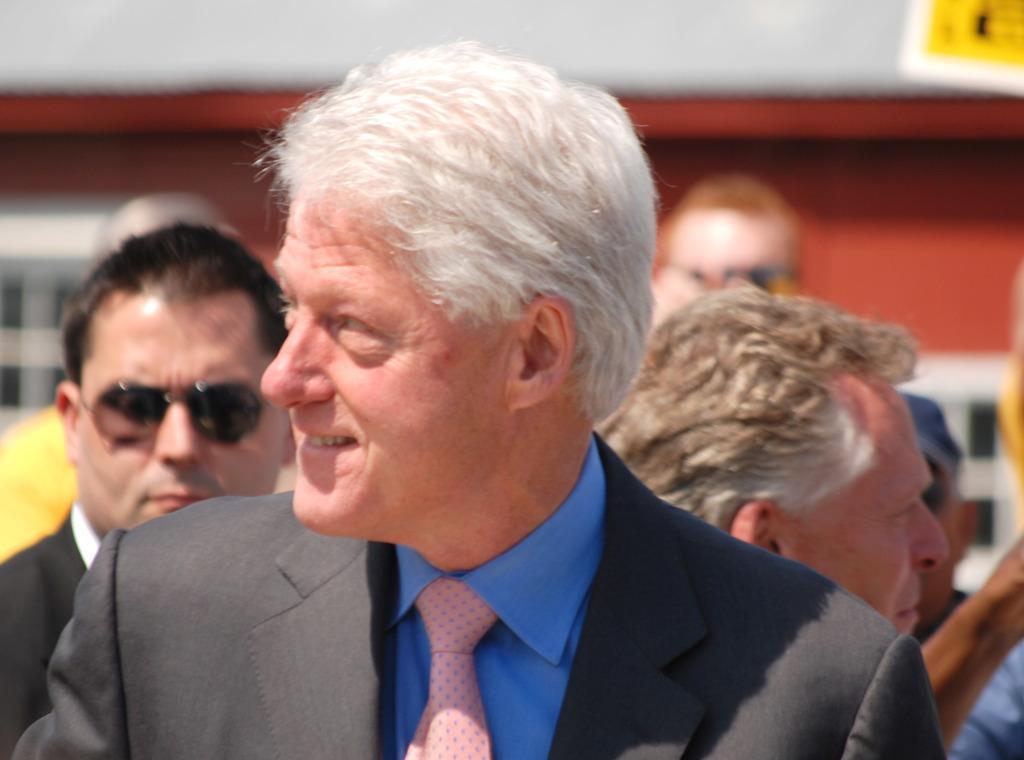Can you describe this image briefly? This image consists of so many persons. In the front there is a man. He is wearing a tie, blazer and a blue shirt. He is smiling. 